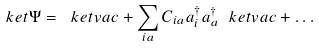<formula> <loc_0><loc_0><loc_500><loc_500>\ k e t { \Psi } = \ k e t { v a c } + \sum _ { i a } C _ { i a } a ^ { \dag } _ { i } a ^ { \dag } _ { a } \ k e t { v a c } + \dots</formula> 